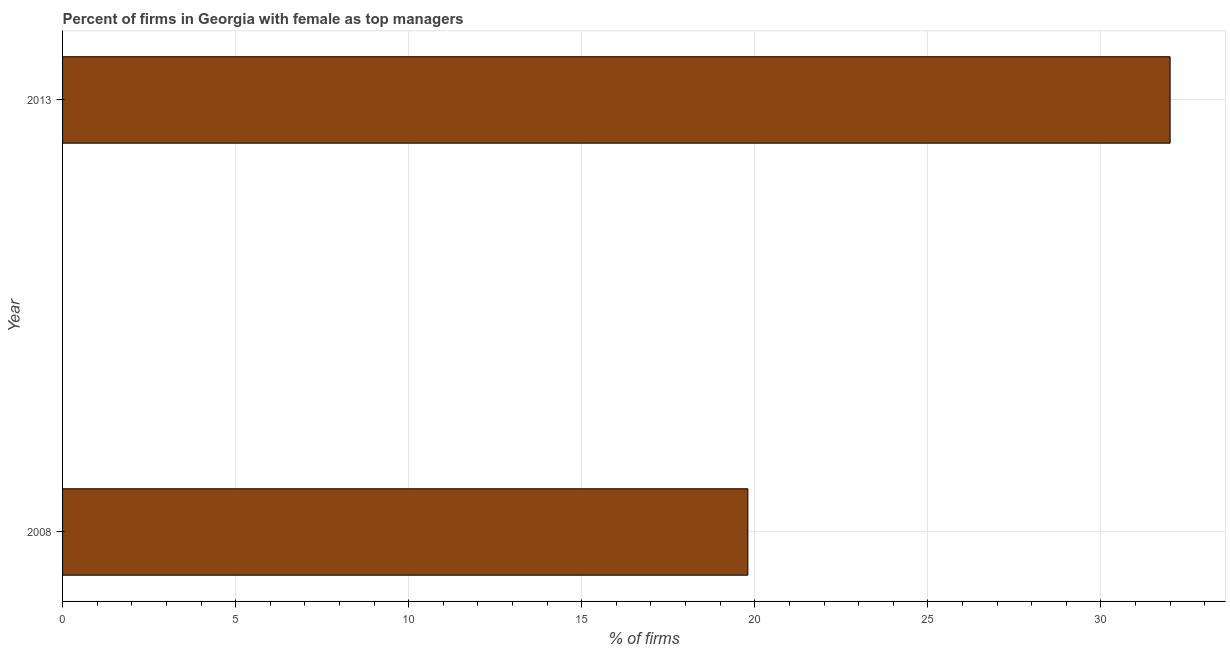Does the graph contain any zero values?
Your answer should be very brief. No. Does the graph contain grids?
Offer a very short reply. Yes. What is the title of the graph?
Offer a terse response. Percent of firms in Georgia with female as top managers. What is the label or title of the X-axis?
Give a very brief answer. % of firms. What is the percentage of firms with female as top manager in 2008?
Give a very brief answer. 19.8. Across all years, what is the minimum percentage of firms with female as top manager?
Your response must be concise. 19.8. In which year was the percentage of firms with female as top manager minimum?
Your answer should be very brief. 2008. What is the sum of the percentage of firms with female as top manager?
Your answer should be compact. 51.8. What is the difference between the percentage of firms with female as top manager in 2008 and 2013?
Provide a succinct answer. -12.2. What is the average percentage of firms with female as top manager per year?
Ensure brevity in your answer.  25.9. What is the median percentage of firms with female as top manager?
Your answer should be compact. 25.9. Do a majority of the years between 2008 and 2013 (inclusive) have percentage of firms with female as top manager greater than 1 %?
Provide a succinct answer. Yes. What is the ratio of the percentage of firms with female as top manager in 2008 to that in 2013?
Your answer should be very brief. 0.62. How many bars are there?
Provide a short and direct response. 2. Are all the bars in the graph horizontal?
Provide a succinct answer. Yes. How many years are there in the graph?
Keep it short and to the point. 2. Are the values on the major ticks of X-axis written in scientific E-notation?
Give a very brief answer. No. What is the % of firms in 2008?
Provide a short and direct response. 19.8. What is the % of firms of 2013?
Offer a terse response. 32. What is the ratio of the % of firms in 2008 to that in 2013?
Ensure brevity in your answer.  0.62. 